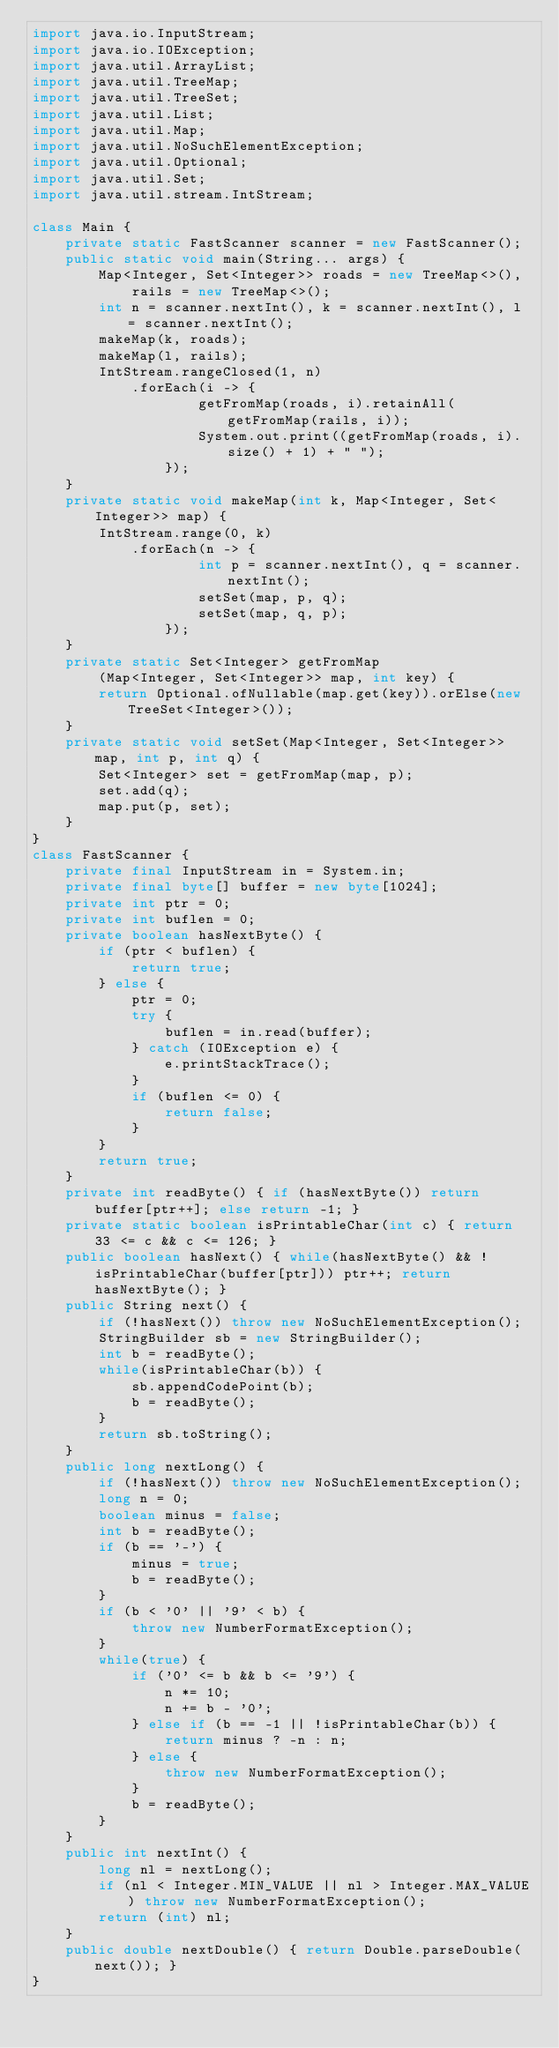Convert code to text. <code><loc_0><loc_0><loc_500><loc_500><_Java_>import java.io.InputStream;
import java.io.IOException;
import java.util.ArrayList;
import java.util.TreeMap;
import java.util.TreeSet;
import java.util.List;
import java.util.Map;
import java.util.NoSuchElementException;
import java.util.Optional;
import java.util.Set;
import java.util.stream.IntStream;

class Main {
    private static FastScanner scanner = new FastScanner();
    public static void main(String... args) {
        Map<Integer, Set<Integer>> roads = new TreeMap<>(),
            rails = new TreeMap<>();
        int n = scanner.nextInt(), k = scanner.nextInt(), l = scanner.nextInt();
        makeMap(k, roads);
        makeMap(l, rails);
        IntStream.rangeClosed(1, n)
            .forEach(i -> {
                    getFromMap(roads, i).retainAll(getFromMap(rails, i));
                    System.out.print((getFromMap(roads, i).size() + 1) + " ");
                });
    }
    private static void makeMap(int k, Map<Integer, Set<Integer>> map) {
        IntStream.range(0, k)
            .forEach(n -> {
                    int p = scanner.nextInt(), q = scanner.nextInt();
                    setSet(map, p, q);
                    setSet(map, q, p);
                });
    }
    private static Set<Integer> getFromMap
        (Map<Integer, Set<Integer>> map, int key) {
        return Optional.ofNullable(map.get(key)).orElse(new TreeSet<Integer>());
    }
    private static void setSet(Map<Integer, Set<Integer>> map, int p, int q) {
        Set<Integer> set = getFromMap(map, p);
        set.add(q);
        map.put(p, set);
    }
}
class FastScanner {
    private final InputStream in = System.in;
    private final byte[] buffer = new byte[1024];
    private int ptr = 0;
    private int buflen = 0;
    private boolean hasNextByte() {
        if (ptr < buflen) {
            return true;
        } else {
            ptr = 0;
            try {
                buflen = in.read(buffer);
            } catch (IOException e) {
                e.printStackTrace();
            }
            if (buflen <= 0) {
                return false;
            }
        }
        return true;
    }
    private int readByte() { if (hasNextByte()) return buffer[ptr++]; else return -1; }
    private static boolean isPrintableChar(int c) { return 33 <= c && c <= 126; }
    public boolean hasNext() { while(hasNextByte() && !isPrintableChar(buffer[ptr])) ptr++; return hasNextByte(); }
    public String next() {
        if (!hasNext()) throw new NoSuchElementException();
        StringBuilder sb = new StringBuilder();
        int b = readByte();
        while(isPrintableChar(b)) {
            sb.appendCodePoint(b);
            b = readByte();
        }
        return sb.toString();
    }
    public long nextLong() {
        if (!hasNext()) throw new NoSuchElementException();
        long n = 0;
        boolean minus = false;
        int b = readByte();
        if (b == '-') {
            minus = true;
            b = readByte();
        }
        if (b < '0' || '9' < b) {
            throw new NumberFormatException();
        }
        while(true) {
            if ('0' <= b && b <= '9') {
                n *= 10;
                n += b - '0';
            } else if (b == -1 || !isPrintableChar(b)) {
                return minus ? -n : n;
            } else {
                throw new NumberFormatException();
            }
            b = readByte();
        }
    }
    public int nextInt() {
        long nl = nextLong();
        if (nl < Integer.MIN_VALUE || nl > Integer.MAX_VALUE) throw new NumberFormatException();
        return (int) nl;
    }
    public double nextDouble() { return Double.parseDouble(next()); }
}</code> 